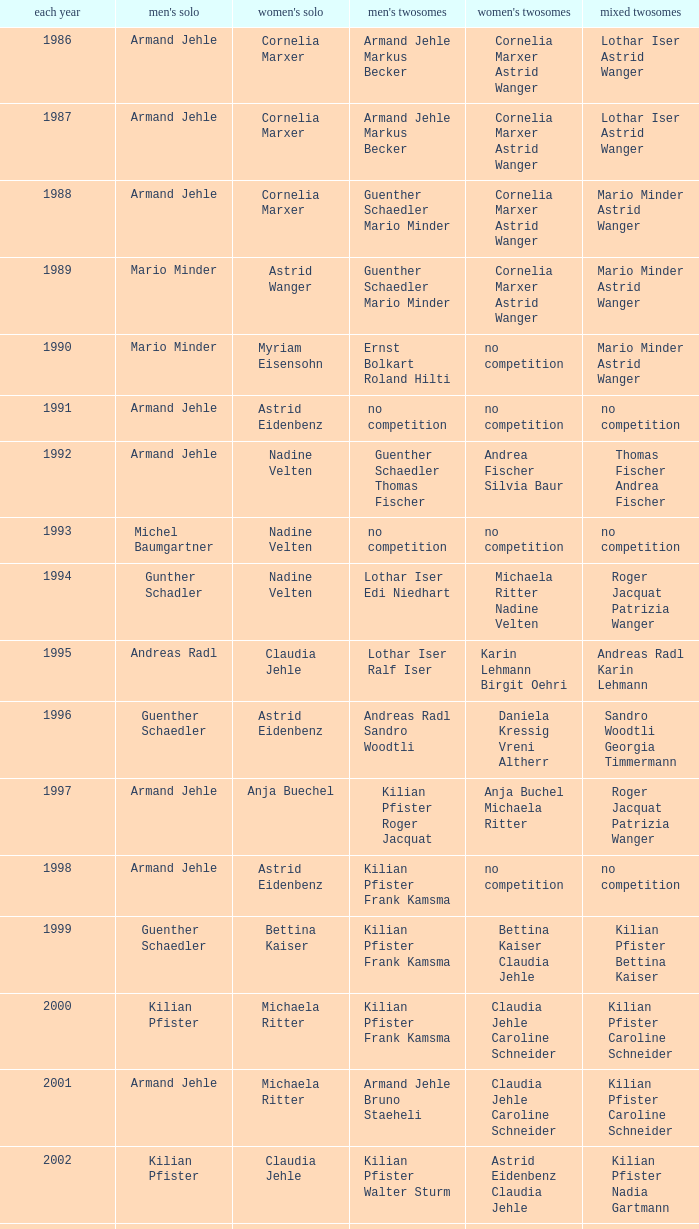In 2001, where the mens singles is armand jehle and the womens singles is michaela ritter, who are the mixed doubles Kilian Pfister Caroline Schneider. 